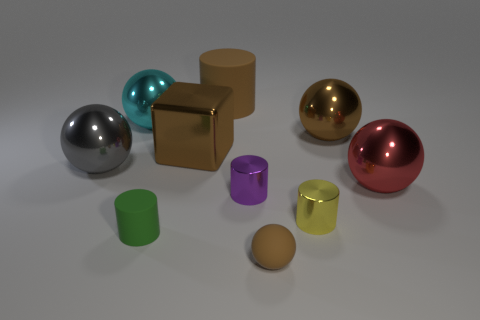Does the thing that is on the left side of the large cyan object have the same shape as the large brown shiny thing that is to the left of the large rubber object?
Offer a very short reply. No. What size is the matte ball that is the same color as the metal cube?
Make the answer very short. Small. How many things are the same color as the metallic cube?
Your answer should be compact. 3. The yellow thing has what shape?
Keep it short and to the point. Cylinder. What number of other objects are the same shape as the yellow object?
Your answer should be very brief. 3. There is a rubber cylinder in front of the big matte object that is behind the cyan shiny object; what is its size?
Offer a terse response. Small. Are any big metallic things visible?
Provide a short and direct response. Yes. What number of tiny purple cylinders are in front of the tiny cylinder that is on the right side of the small rubber ball?
Offer a terse response. 0. What shape is the big brown object that is right of the tiny sphere?
Your answer should be compact. Sphere. What is the material of the brown thing in front of the large ball that is in front of the thing on the left side of the big cyan shiny object?
Offer a terse response. Rubber. 